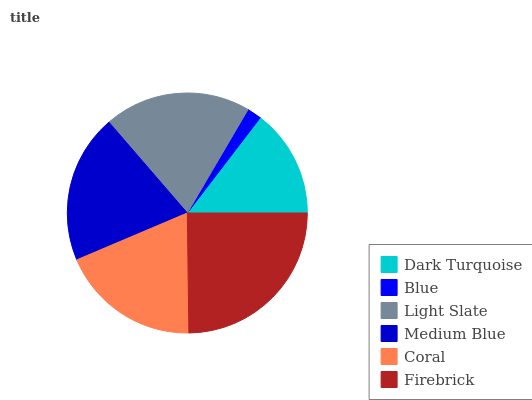Is Blue the minimum?
Answer yes or no. Yes. Is Firebrick the maximum?
Answer yes or no. Yes. Is Light Slate the minimum?
Answer yes or no. No. Is Light Slate the maximum?
Answer yes or no. No. Is Light Slate greater than Blue?
Answer yes or no. Yes. Is Blue less than Light Slate?
Answer yes or no. Yes. Is Blue greater than Light Slate?
Answer yes or no. No. Is Light Slate less than Blue?
Answer yes or no. No. Is Light Slate the high median?
Answer yes or no. Yes. Is Coral the low median?
Answer yes or no. Yes. Is Firebrick the high median?
Answer yes or no. No. Is Medium Blue the low median?
Answer yes or no. No. 